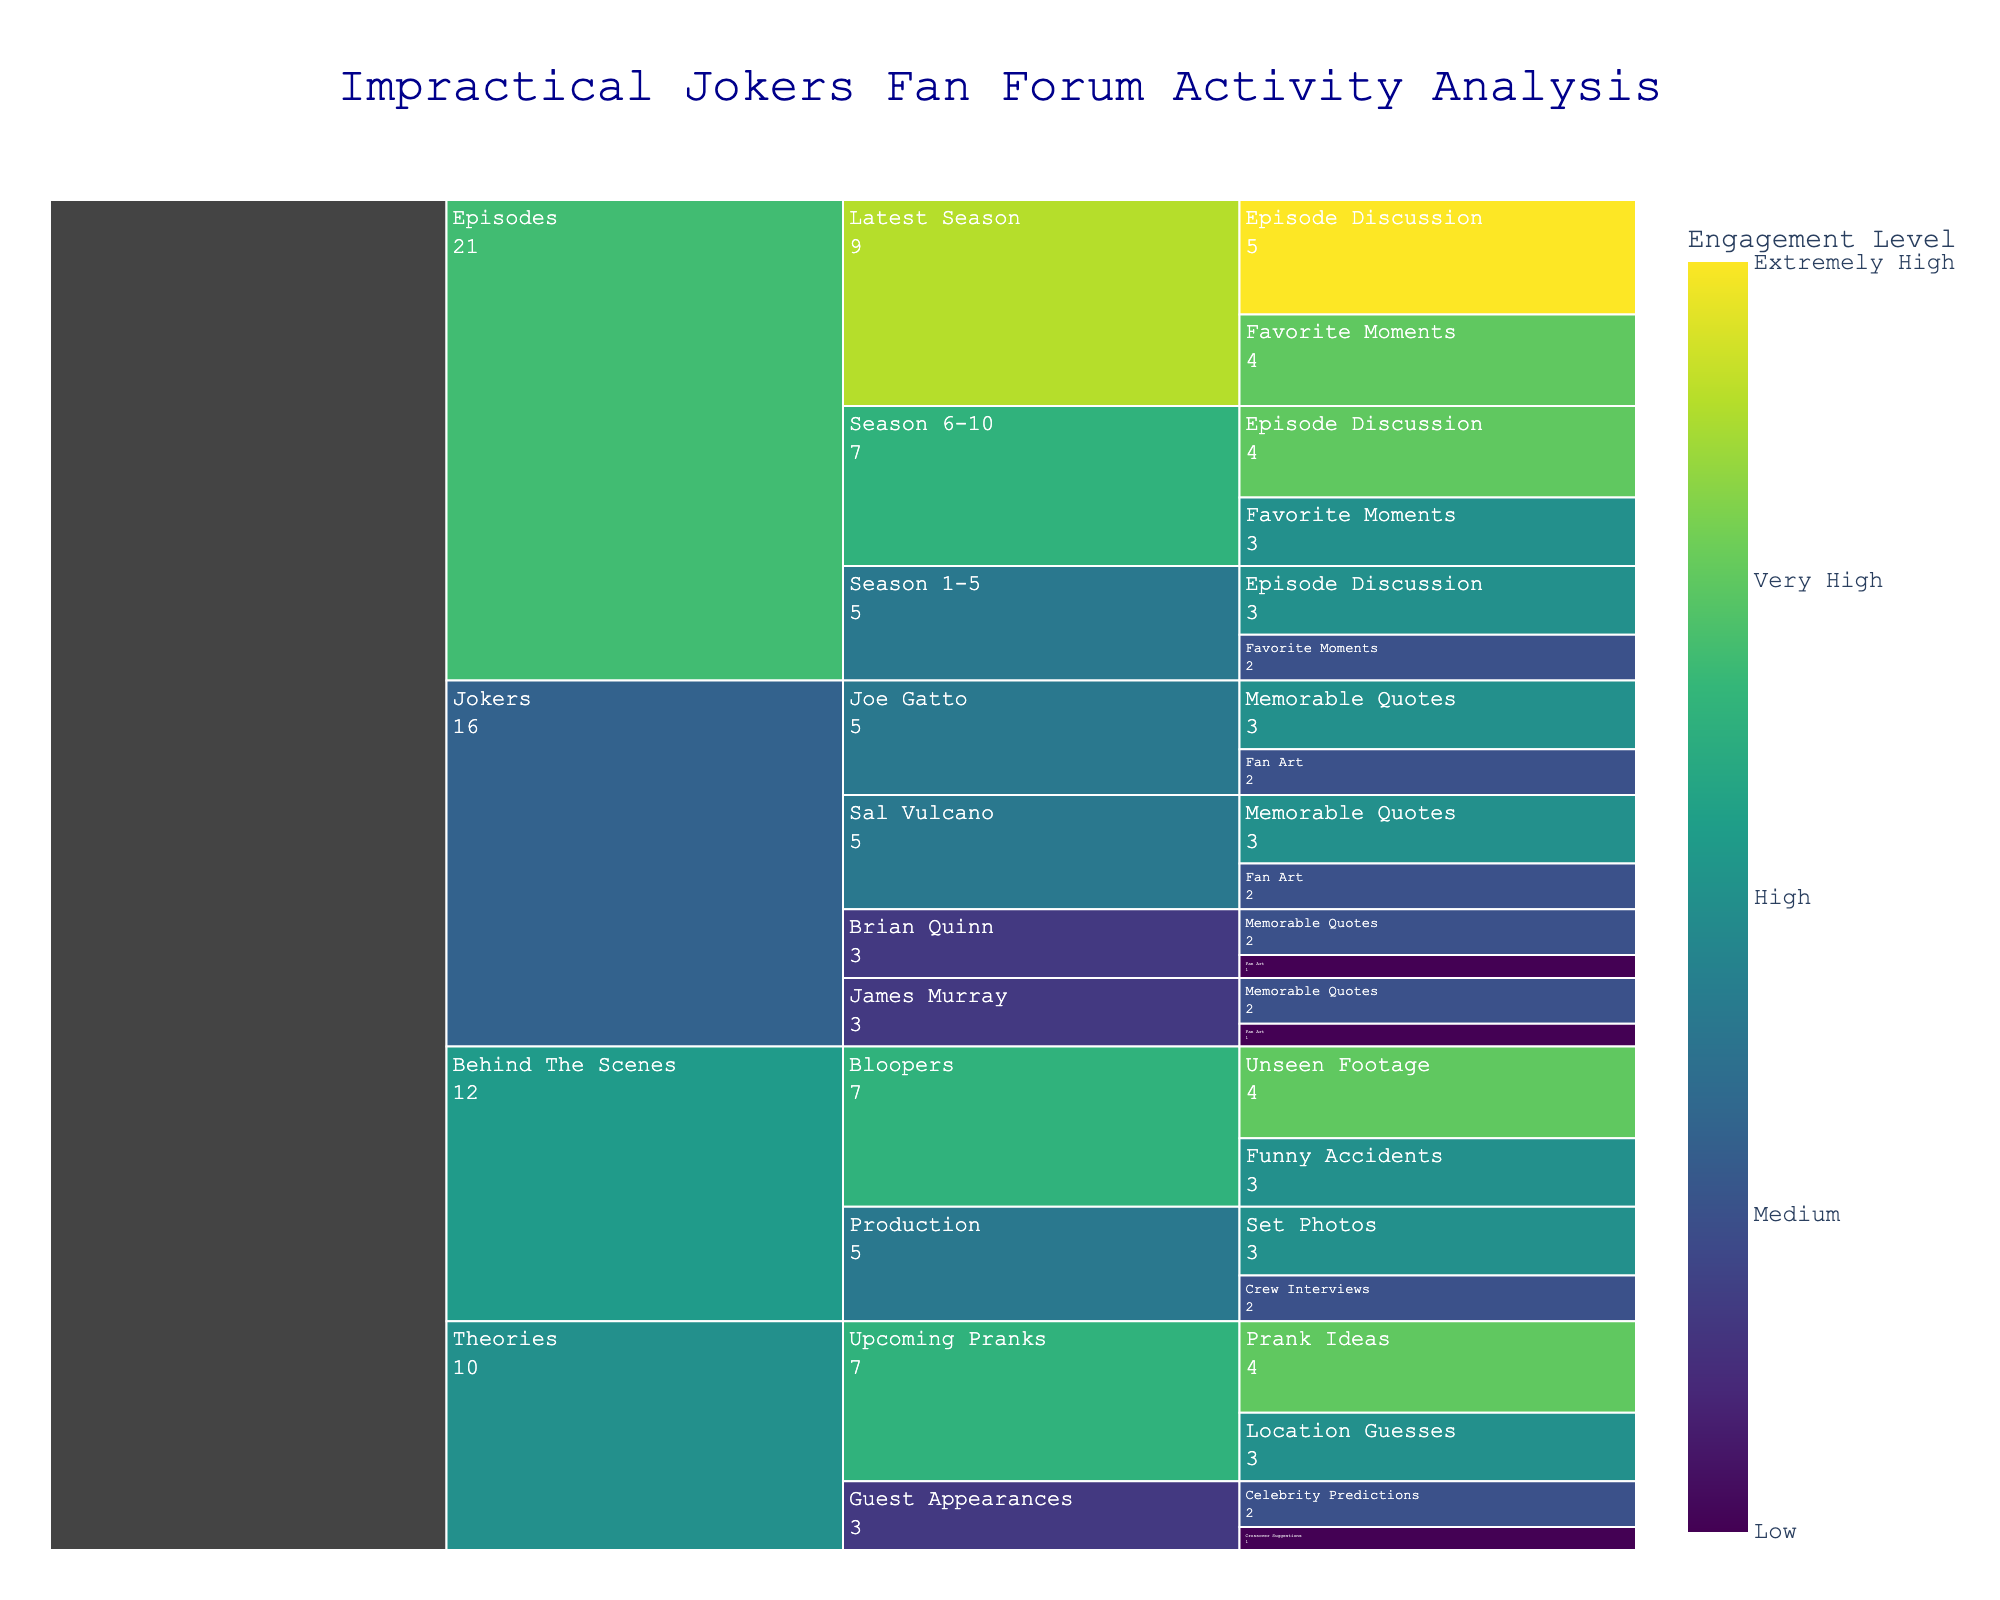How many categories are there in the figure? The icicle chart shows four main categories based on the initial data: 'Episodes', 'Jokers', 'Theories', and 'Behind The Scenes'.
Answer: 4 Which subcategory has the highest engagement value in the 'Episodes' category? Within the 'Episodes' category, the 'Latest Season' subcategory has 'Extremely High' engagement, which is the highest value.
Answer: Latest Season How does the engagement level for 'Episode Discussion' posts in 'Season 1-5' compare to 'Season 6-10'? 'Episode Discussion' in 'Season 1-5' has a 'High' engagement level, while 'Season 6-10' has a 'Very High' engagement level. 'Season 6-10' is higher.
Answer: Season 6-10 is higher What is the overall engagement level for posts about 'Sal Vulcano'? 'Fan Art' for Sal Vulcano has a 'Medium' engagement level, and 'Memorable Quotes' has a 'High' engagement level. Summing the numeric values (Medium=2, High=3) gives 2+3=5.
Answer: 5 Which post type has a higher engagement in the 'Upcoming Pranks' subcategory: 'Location Guesses' or 'Prank Ideas'? 'Prank Ideas' post type in 'Upcoming Pranks' subcategory has a 'Very High' engagement level, while 'Location Guesses' has a 'High' engagement level. 'Prank Ideas' is higher.
Answer: Prank Ideas What is the most engaged subcategory in the 'Behind The Scenes' category? The 'Bloopers' subcategory has the highest engagement with 'Unseen Footage' reaching 'Very High' and 'Funny Accidents' at 'High'. 'Very High' is the highest single level, making 'Bloopers' the most engaged.
Answer: Bloopers How does the overall engagement for 'Fan Art' posts compare between 'Joe Gatto' and 'James Murray'? 'Fan Art' for Joe Gatto has a 'Medium' engagement level (2), while 'Fan Art' for James Murray has a 'Low' engagement level (1). Summing the numeric values, Joe Gatto has 2, James Murray has 1. Joe Gatto's total is higher.
Answer: Joe Gatto is higher What is the engagement level for 'Set Photos' in the 'Production' subcategory? In the 'Production' subcategory under 'Behind The Scenes', 'Set Photos' has a 'High' engagement level.
Answer: High 